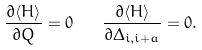<formula> <loc_0><loc_0><loc_500><loc_500>\frac { \partial \langle H \rangle } { \partial Q } = 0 \quad \frac { \partial \langle H \rangle } { \partial \Delta _ { i , i + { a } } } = 0 .</formula> 